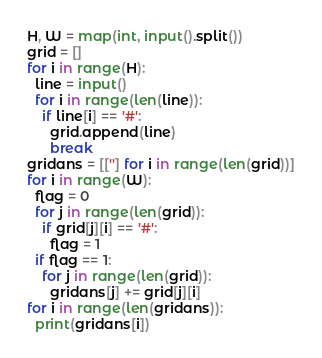<code> <loc_0><loc_0><loc_500><loc_500><_Python_>H, W = map(int, input().split())
grid = []
for i in range(H):
  line = input()
  for i in range(len(line)):
    if line[i] == '#':
      grid.append(line)
      break
gridans = [[''] for i in range(len(grid))]
for i in range(W):
  flag = 0
  for j in range(len(grid)):
    if grid[j][i] == '#':
      flag = 1
  if flag == 1:
    for j in range(len(grid)):
      gridans[j] += grid[j][i]
for i in range(len(gridans)):
  print(gridans[i])
</code> 